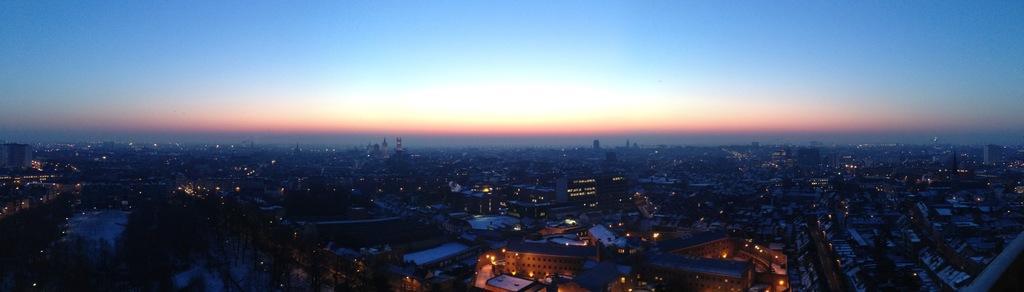Can you describe this image briefly? This image is an aerial view. In this image there are buildings and we can see lights. In the background there is sky. 